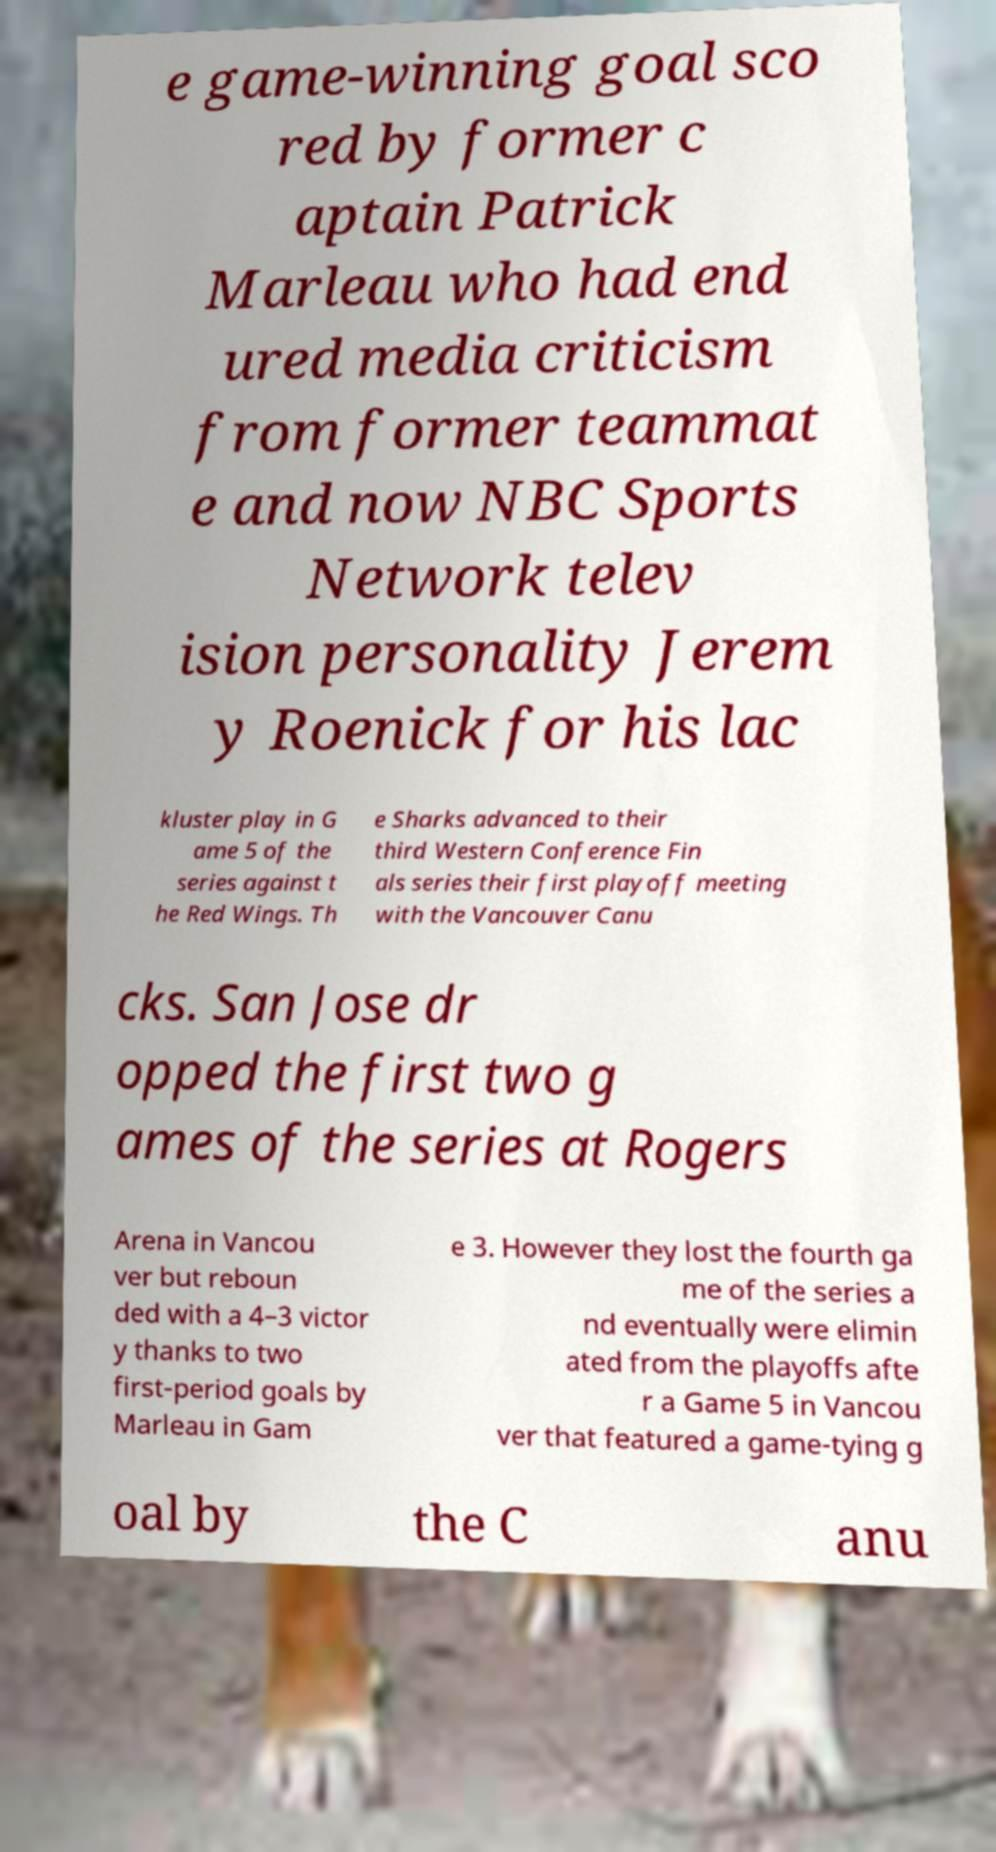For documentation purposes, I need the text within this image transcribed. Could you provide that? e game-winning goal sco red by former c aptain Patrick Marleau who had end ured media criticism from former teammat e and now NBC Sports Network telev ision personality Jerem y Roenick for his lac kluster play in G ame 5 of the series against t he Red Wings. Th e Sharks advanced to their third Western Conference Fin als series their first playoff meeting with the Vancouver Canu cks. San Jose dr opped the first two g ames of the series at Rogers Arena in Vancou ver but reboun ded with a 4–3 victor y thanks to two first-period goals by Marleau in Gam e 3. However they lost the fourth ga me of the series a nd eventually were elimin ated from the playoffs afte r a Game 5 in Vancou ver that featured a game-tying g oal by the C anu 